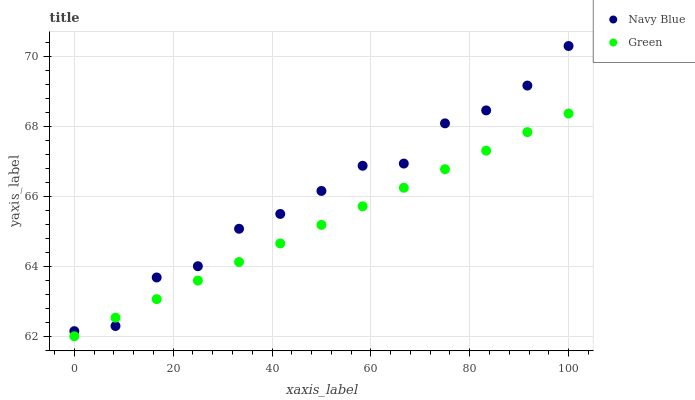Does Green have the minimum area under the curve?
Answer yes or no. Yes. Does Navy Blue have the maximum area under the curve?
Answer yes or no. Yes. Does Green have the maximum area under the curve?
Answer yes or no. No. Is Green the smoothest?
Answer yes or no. Yes. Is Navy Blue the roughest?
Answer yes or no. Yes. Is Green the roughest?
Answer yes or no. No. Does Green have the lowest value?
Answer yes or no. Yes. Does Navy Blue have the highest value?
Answer yes or no. Yes. Does Green have the highest value?
Answer yes or no. No. Does Green intersect Navy Blue?
Answer yes or no. Yes. Is Green less than Navy Blue?
Answer yes or no. No. Is Green greater than Navy Blue?
Answer yes or no. No. 